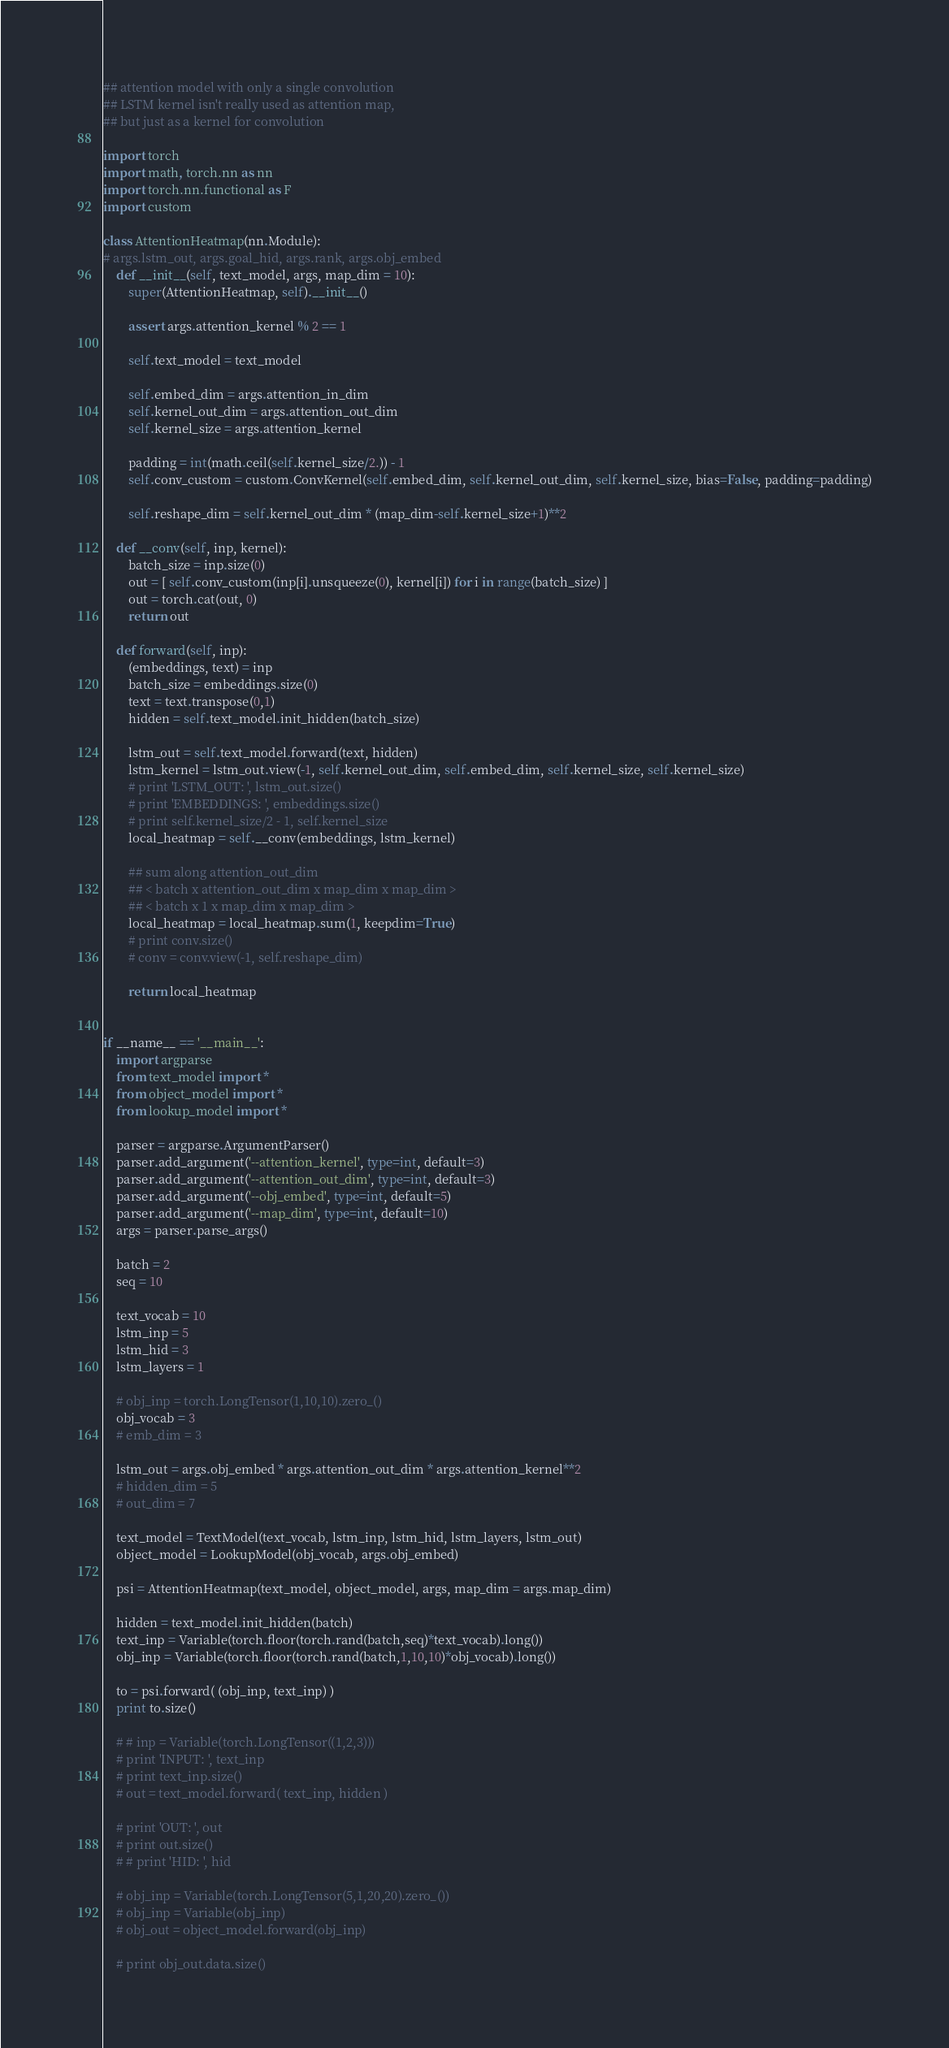<code> <loc_0><loc_0><loc_500><loc_500><_Python_>## attention model with only a single convolution
## LSTM kernel isn't really used as attention map,
## but just as a kernel for convolution

import torch
import math, torch.nn as nn
import torch.nn.functional as F
import custom

class AttentionHeatmap(nn.Module):
# args.lstm_out, args.goal_hid, args.rank, args.obj_embed
    def __init__(self, text_model, args, map_dim = 10):
        super(AttentionHeatmap, self).__init__()
        
        assert args.attention_kernel % 2 == 1

        self.text_model = text_model

        self.embed_dim = args.attention_in_dim
        self.kernel_out_dim = args.attention_out_dim
        self.kernel_size = args.attention_kernel 

        padding = int(math.ceil(self.kernel_size/2.)) - 1
        self.conv_custom = custom.ConvKernel(self.embed_dim, self.kernel_out_dim, self.kernel_size, bias=False, padding=padding)

        self.reshape_dim = self.kernel_out_dim * (map_dim-self.kernel_size+1)**2

    def __conv(self, inp, kernel):
        batch_size = inp.size(0)
        out = [ self.conv_custom(inp[i].unsqueeze(0), kernel[i]) for i in range(batch_size) ]
        out = torch.cat(out, 0)
        return out

    def forward(self, inp):
        (embeddings, text) = inp
        batch_size = embeddings.size(0)
        text = text.transpose(0,1)
        hidden = self.text_model.init_hidden(batch_size)

        lstm_out = self.text_model.forward(text, hidden)
        lstm_kernel = lstm_out.view(-1, self.kernel_out_dim, self.embed_dim, self.kernel_size, self.kernel_size)
        # print 'LSTM_OUT: ', lstm_out.size()
        # print 'EMBEDDINGS: ', embeddings.size()
        # print self.kernel_size/2 - 1, self.kernel_size
        local_heatmap = self.__conv(embeddings, lstm_kernel)

        ## sum along attention_out_dim
        ## < batch x attention_out_dim x map_dim x map_dim >
        ## < batch x 1 x map_dim x map_dim >
        local_heatmap = local_heatmap.sum(1, keepdim=True)
        # print conv.size()
        # conv = conv.view(-1, self.reshape_dim)

        return local_heatmap


if __name__ == '__main__':
    import argparse
    from text_model import *
    from object_model import *
    from lookup_model import *

    parser = argparse.ArgumentParser()
    parser.add_argument('--attention_kernel', type=int, default=3)
    parser.add_argument('--attention_out_dim', type=int, default=3)
    parser.add_argument('--obj_embed', type=int, default=5)
    parser.add_argument('--map_dim', type=int, default=10)
    args = parser.parse_args()

    batch = 2
    seq = 10

    text_vocab = 10
    lstm_inp = 5
    lstm_hid = 3
    lstm_layers = 1

    # obj_inp = torch.LongTensor(1,10,10).zero_()
    obj_vocab = 3
    # emb_dim = 3

    lstm_out = args.obj_embed * args.attention_out_dim * args.attention_kernel**2
    # hidden_dim = 5
    # out_dim = 7

    text_model = TextModel(text_vocab, lstm_inp, lstm_hid, lstm_layers, lstm_out)
    object_model = LookupModel(obj_vocab, args.obj_embed)

    psi = AttentionHeatmap(text_model, object_model, args, map_dim = args.map_dim)

    hidden = text_model.init_hidden(batch)
    text_inp = Variable(torch.floor(torch.rand(batch,seq)*text_vocab).long())
    obj_inp = Variable(torch.floor(torch.rand(batch,1,10,10)*obj_vocab).long())

    to = psi.forward( (obj_inp, text_inp) )
    print to.size()

    # # inp = Variable(torch.LongTensor((1,2,3)))
    # print 'INPUT: ', text_inp
    # print text_inp.size()
    # out = text_model.forward( text_inp, hidden )

    # print 'OUT: ', out
    # print out.size()
    # # print 'HID: ', hid

    # obj_inp = Variable(torch.LongTensor(5,1,20,20).zero_())
    # obj_inp = Variable(obj_inp)
    # obj_out = object_model.forward(obj_inp)

    # print obj_out.data.size()








</code> 